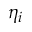Convert formula to latex. <formula><loc_0><loc_0><loc_500><loc_500>\eta _ { i }</formula> 